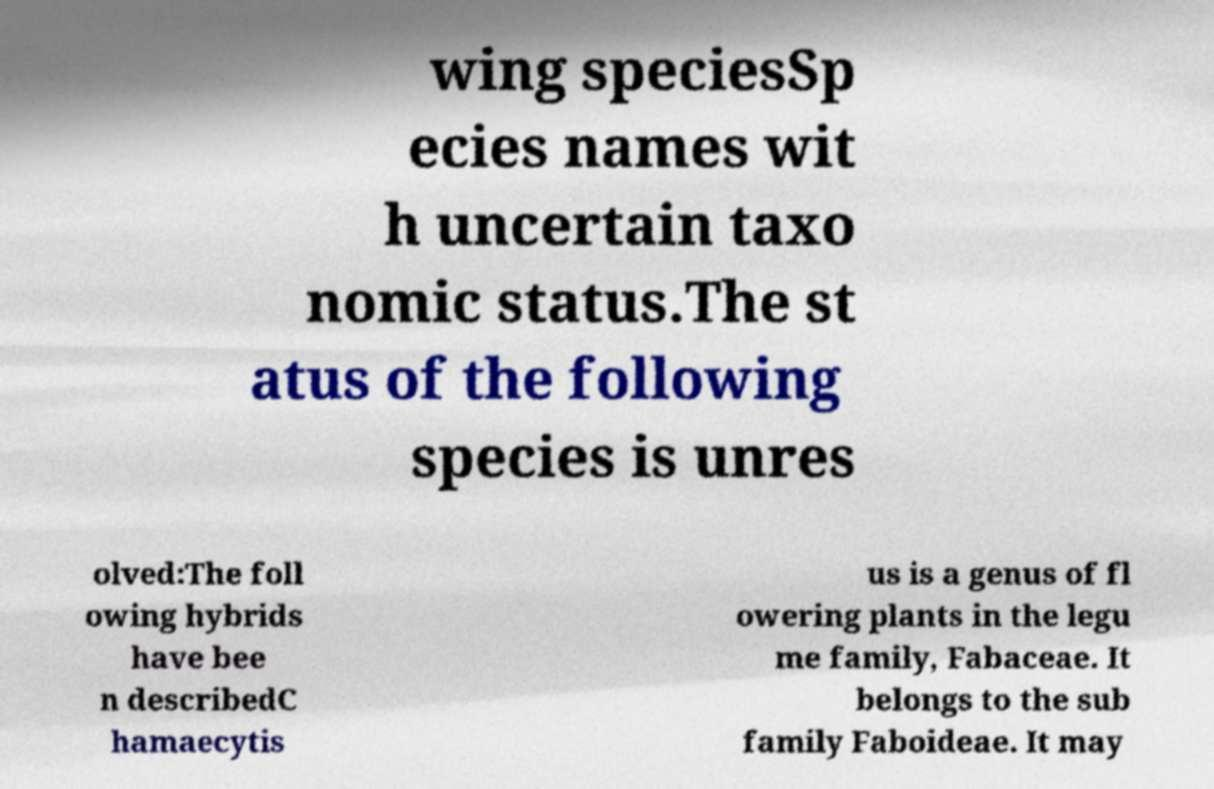Can you accurately transcribe the text from the provided image for me? wing speciesSp ecies names wit h uncertain taxo nomic status.The st atus of the following species is unres olved:The foll owing hybrids have bee n describedC hamaecytis us is a genus of fl owering plants in the legu me family, Fabaceae. It belongs to the sub family Faboideae. It may 